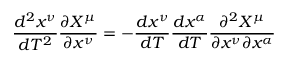<formula> <loc_0><loc_0><loc_500><loc_500>{ \frac { d ^ { 2 } x ^ { \nu } } { d T ^ { 2 } } } { \frac { \partial X ^ { \mu } } { \partial x ^ { \nu } } } = - { \frac { d x ^ { \nu } } { d T } } { \frac { d x ^ { \alpha } } { d T } } { \frac { \partial ^ { 2 } X ^ { \mu } } { \partial x ^ { \nu } \partial x ^ { \alpha } } }</formula> 